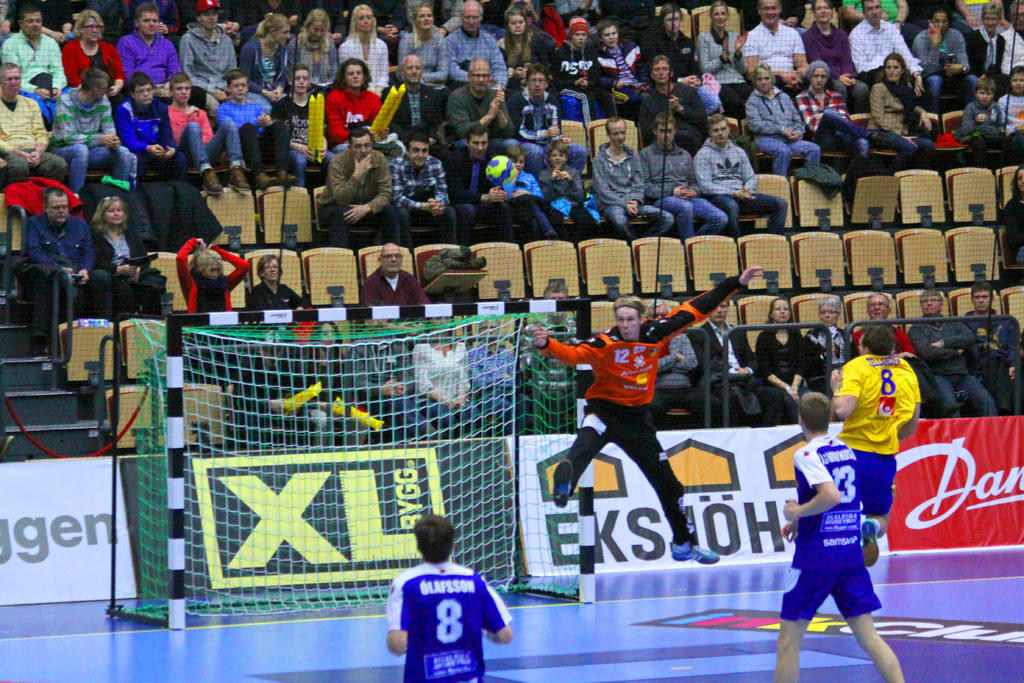Can you tell me more about the team colors or uniforms? Yes, the attacking team is wearing yellow uniforms, which is a common color for sports teams due to its visibility. The goalkeeper is dressed in black, contrasting with the team color to stand out as the last line of defense. 